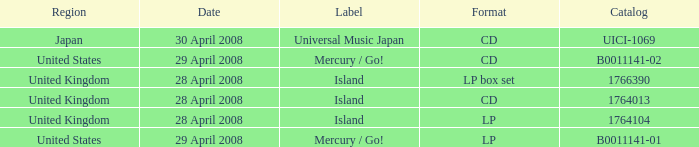What is the Label of the B0011141-01 Catalog? Mercury / Go!. Can you give me this table as a dict? {'header': ['Region', 'Date', 'Label', 'Format', 'Catalog'], 'rows': [['Japan', '30 April 2008', 'Universal Music Japan', 'CD', 'UICI-1069'], ['United States', '29 April 2008', 'Mercury / Go!', 'CD', 'B0011141-02'], ['United Kingdom', '28 April 2008', 'Island', 'LP box set', '1766390'], ['United Kingdom', '28 April 2008', 'Island', 'CD', '1764013'], ['United Kingdom', '28 April 2008', 'Island', 'LP', '1764104'], ['United States', '29 April 2008', 'Mercury / Go!', 'LP', 'B0011141-01']]} 